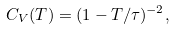Convert formula to latex. <formula><loc_0><loc_0><loc_500><loc_500>C _ { V } ( T ) = ( 1 - T / \tau ) ^ { - 2 } ,</formula> 